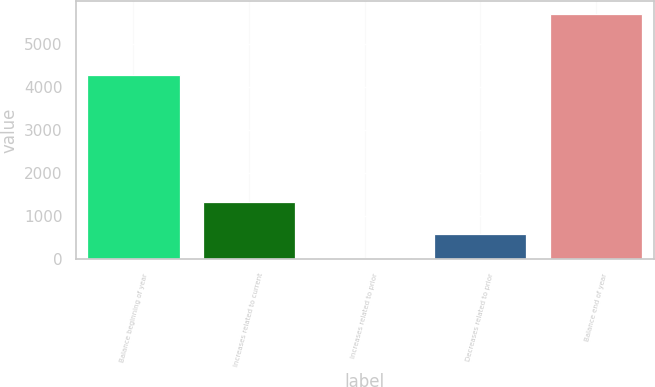Convert chart. <chart><loc_0><loc_0><loc_500><loc_500><bar_chart><fcel>Balance beginning of year<fcel>Increases related to current<fcel>Increases related to prior<fcel>Decreases related to prior<fcel>Balance end of year<nl><fcel>4276<fcel>1333<fcel>19<fcel>586.8<fcel>5697<nl></chart> 